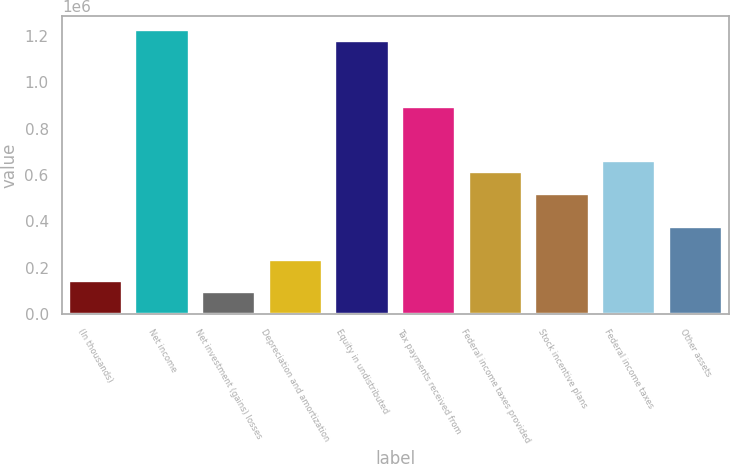<chart> <loc_0><loc_0><loc_500><loc_500><bar_chart><fcel>(In thousands)<fcel>Net income<fcel>Net investment (gains) losses<fcel>Depreciation and amortization<fcel>Equity in undistributed<fcel>Tax payments received from<fcel>Federal income taxes provided<fcel>Stock incentive plans<fcel>Federal income taxes<fcel>Other assets<nl><fcel>141304<fcel>1.22461e+06<fcel>94203.8<fcel>235505<fcel>1.17751e+06<fcel>894911<fcel>612308<fcel>518107<fcel>659409<fcel>376806<nl></chart> 